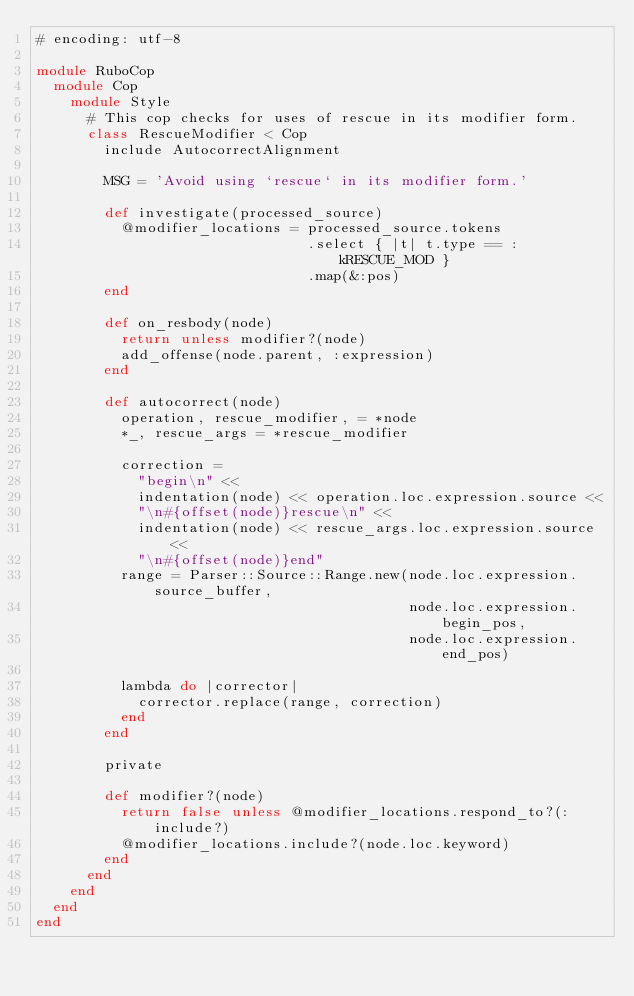<code> <loc_0><loc_0><loc_500><loc_500><_Ruby_># encoding: utf-8

module RuboCop
  module Cop
    module Style
      # This cop checks for uses of rescue in its modifier form.
      class RescueModifier < Cop
        include AutocorrectAlignment

        MSG = 'Avoid using `rescue` in its modifier form.'

        def investigate(processed_source)
          @modifier_locations = processed_source.tokens
                                .select { |t| t.type == :kRESCUE_MOD }
                                .map(&:pos)
        end

        def on_resbody(node)
          return unless modifier?(node)
          add_offense(node.parent, :expression)
        end

        def autocorrect(node)
          operation, rescue_modifier, = *node
          *_, rescue_args = *rescue_modifier

          correction =
            "begin\n" <<
            indentation(node) << operation.loc.expression.source <<
            "\n#{offset(node)}rescue\n" <<
            indentation(node) << rescue_args.loc.expression.source <<
            "\n#{offset(node)}end"
          range = Parser::Source::Range.new(node.loc.expression.source_buffer,
                                            node.loc.expression.begin_pos,
                                            node.loc.expression.end_pos)

          lambda do |corrector|
            corrector.replace(range, correction)
          end
        end

        private

        def modifier?(node)
          return false unless @modifier_locations.respond_to?(:include?)
          @modifier_locations.include?(node.loc.keyword)
        end
      end
    end
  end
end
</code> 